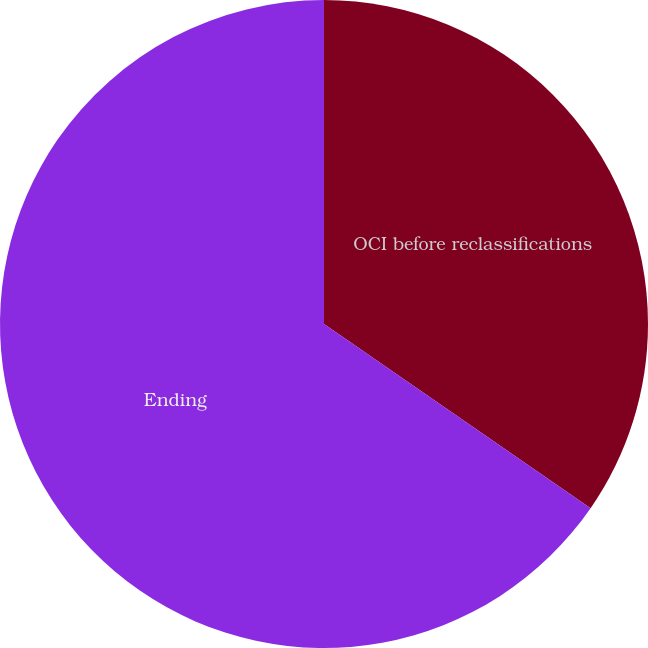Convert chart. <chart><loc_0><loc_0><loc_500><loc_500><pie_chart><fcel>OCI before reclassifications<fcel>Ending<nl><fcel>34.62%<fcel>65.38%<nl></chart> 